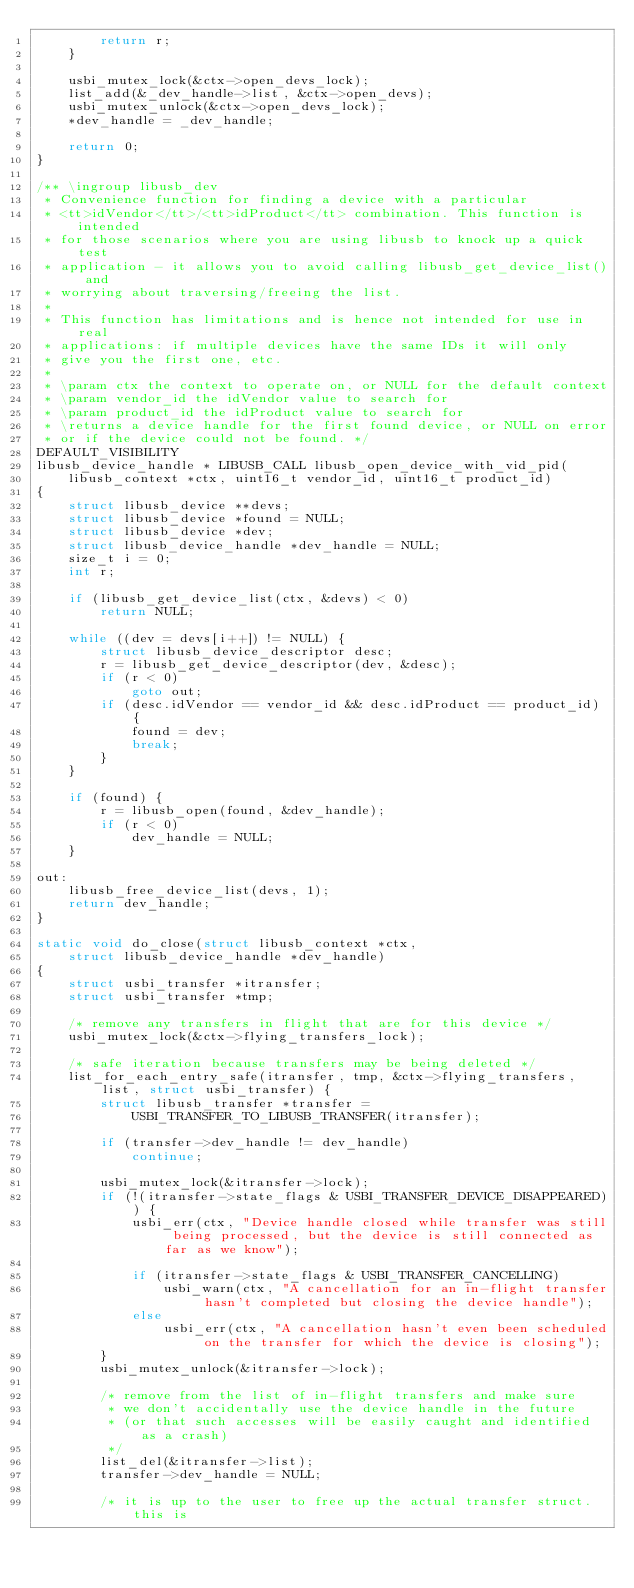<code> <loc_0><loc_0><loc_500><loc_500><_C_>        return r;
    }

    usbi_mutex_lock(&ctx->open_devs_lock);
    list_add(&_dev_handle->list, &ctx->open_devs);
    usbi_mutex_unlock(&ctx->open_devs_lock);
    *dev_handle = _dev_handle;

    return 0;
}

/** \ingroup libusb_dev
 * Convenience function for finding a device with a particular
 * <tt>idVendor</tt>/<tt>idProduct</tt> combination. This function is intended
 * for those scenarios where you are using libusb to knock up a quick test
 * application - it allows you to avoid calling libusb_get_device_list() and
 * worrying about traversing/freeing the list.
 *
 * This function has limitations and is hence not intended for use in real
 * applications: if multiple devices have the same IDs it will only
 * give you the first one, etc.
 *
 * \param ctx the context to operate on, or NULL for the default context
 * \param vendor_id the idVendor value to search for
 * \param product_id the idProduct value to search for
 * \returns a device handle for the first found device, or NULL on error
 * or if the device could not be found. */
DEFAULT_VISIBILITY
libusb_device_handle * LIBUSB_CALL libusb_open_device_with_vid_pid(
    libusb_context *ctx, uint16_t vendor_id, uint16_t product_id)
{
    struct libusb_device **devs;
    struct libusb_device *found = NULL;
    struct libusb_device *dev;
    struct libusb_device_handle *dev_handle = NULL;
    size_t i = 0;
    int r;

    if (libusb_get_device_list(ctx, &devs) < 0)
        return NULL;

    while ((dev = devs[i++]) != NULL) {
        struct libusb_device_descriptor desc;
        r = libusb_get_device_descriptor(dev, &desc);
        if (r < 0)
            goto out;
        if (desc.idVendor == vendor_id && desc.idProduct == product_id) {
            found = dev;
            break;
        }
    }

    if (found) {
        r = libusb_open(found, &dev_handle);
        if (r < 0)
            dev_handle = NULL;
    }

out:
    libusb_free_device_list(devs, 1);
    return dev_handle;
}

static void do_close(struct libusb_context *ctx,
    struct libusb_device_handle *dev_handle)
{
    struct usbi_transfer *itransfer;
    struct usbi_transfer *tmp;

    /* remove any transfers in flight that are for this device */
    usbi_mutex_lock(&ctx->flying_transfers_lock);

    /* safe iteration because transfers may be being deleted */
    list_for_each_entry_safe(itransfer, tmp, &ctx->flying_transfers, list, struct usbi_transfer) {
        struct libusb_transfer *transfer =
            USBI_TRANSFER_TO_LIBUSB_TRANSFER(itransfer);

        if (transfer->dev_handle != dev_handle)
            continue;

        usbi_mutex_lock(&itransfer->lock);
        if (!(itransfer->state_flags & USBI_TRANSFER_DEVICE_DISAPPEARED)) {
            usbi_err(ctx, "Device handle closed while transfer was still being processed, but the device is still connected as far as we know");

            if (itransfer->state_flags & USBI_TRANSFER_CANCELLING)
                usbi_warn(ctx, "A cancellation for an in-flight transfer hasn't completed but closing the device handle");
            else
                usbi_err(ctx, "A cancellation hasn't even been scheduled on the transfer for which the device is closing");
        }
        usbi_mutex_unlock(&itransfer->lock);

        /* remove from the list of in-flight transfers and make sure
         * we don't accidentally use the device handle in the future
         * (or that such accesses will be easily caught and identified as a crash)
         */
        list_del(&itransfer->list);
        transfer->dev_handle = NULL;

        /* it is up to the user to free up the actual transfer struct.  this is</code> 